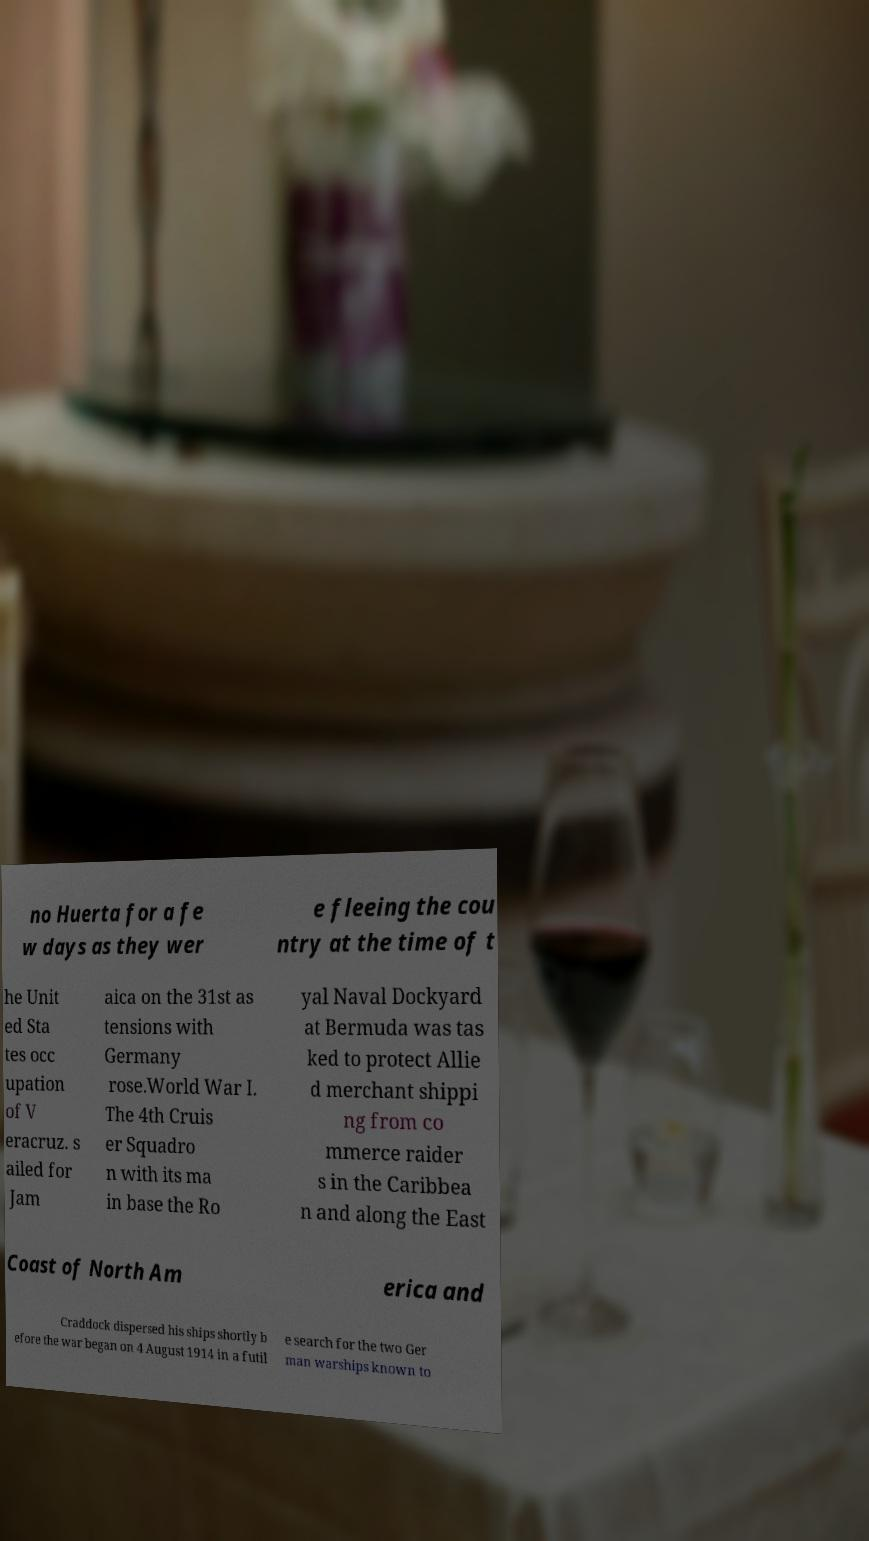Please identify and transcribe the text found in this image. no Huerta for a fe w days as they wer e fleeing the cou ntry at the time of t he Unit ed Sta tes occ upation of V eracruz. s ailed for Jam aica on the 31st as tensions with Germany rose.World War I. The 4th Cruis er Squadro n with its ma in base the Ro yal Naval Dockyard at Bermuda was tas ked to protect Allie d merchant shippi ng from co mmerce raider s in the Caribbea n and along the East Coast of North Am erica and Craddock dispersed his ships shortly b efore the war began on 4 August 1914 in a futil e search for the two Ger man warships known to 